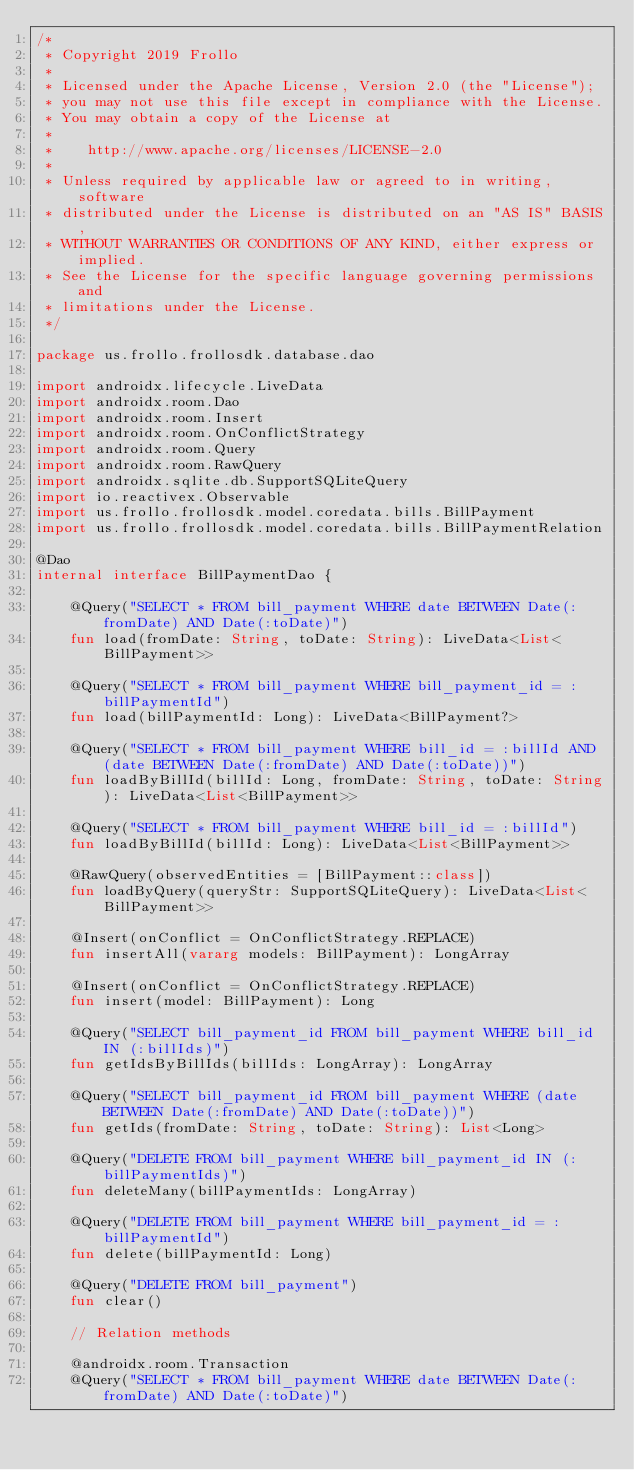Convert code to text. <code><loc_0><loc_0><loc_500><loc_500><_Kotlin_>/*
 * Copyright 2019 Frollo
 *
 * Licensed under the Apache License, Version 2.0 (the "License");
 * you may not use this file except in compliance with the License.
 * You may obtain a copy of the License at
 *
 *    http://www.apache.org/licenses/LICENSE-2.0
 *
 * Unless required by applicable law or agreed to in writing, software
 * distributed under the License is distributed on an "AS IS" BASIS,
 * WITHOUT WARRANTIES OR CONDITIONS OF ANY KIND, either express or implied.
 * See the License for the specific language governing permissions and
 * limitations under the License.
 */

package us.frollo.frollosdk.database.dao

import androidx.lifecycle.LiveData
import androidx.room.Dao
import androidx.room.Insert
import androidx.room.OnConflictStrategy
import androidx.room.Query
import androidx.room.RawQuery
import androidx.sqlite.db.SupportSQLiteQuery
import io.reactivex.Observable
import us.frollo.frollosdk.model.coredata.bills.BillPayment
import us.frollo.frollosdk.model.coredata.bills.BillPaymentRelation

@Dao
internal interface BillPaymentDao {

    @Query("SELECT * FROM bill_payment WHERE date BETWEEN Date(:fromDate) AND Date(:toDate)")
    fun load(fromDate: String, toDate: String): LiveData<List<BillPayment>>

    @Query("SELECT * FROM bill_payment WHERE bill_payment_id = :billPaymentId")
    fun load(billPaymentId: Long): LiveData<BillPayment?>

    @Query("SELECT * FROM bill_payment WHERE bill_id = :billId AND (date BETWEEN Date(:fromDate) AND Date(:toDate))")
    fun loadByBillId(billId: Long, fromDate: String, toDate: String): LiveData<List<BillPayment>>

    @Query("SELECT * FROM bill_payment WHERE bill_id = :billId")
    fun loadByBillId(billId: Long): LiveData<List<BillPayment>>

    @RawQuery(observedEntities = [BillPayment::class])
    fun loadByQuery(queryStr: SupportSQLiteQuery): LiveData<List<BillPayment>>

    @Insert(onConflict = OnConflictStrategy.REPLACE)
    fun insertAll(vararg models: BillPayment): LongArray

    @Insert(onConflict = OnConflictStrategy.REPLACE)
    fun insert(model: BillPayment): Long

    @Query("SELECT bill_payment_id FROM bill_payment WHERE bill_id IN (:billIds)")
    fun getIdsByBillIds(billIds: LongArray): LongArray

    @Query("SELECT bill_payment_id FROM bill_payment WHERE (date BETWEEN Date(:fromDate) AND Date(:toDate))")
    fun getIds(fromDate: String, toDate: String): List<Long>

    @Query("DELETE FROM bill_payment WHERE bill_payment_id IN (:billPaymentIds)")
    fun deleteMany(billPaymentIds: LongArray)

    @Query("DELETE FROM bill_payment WHERE bill_payment_id = :billPaymentId")
    fun delete(billPaymentId: Long)

    @Query("DELETE FROM bill_payment")
    fun clear()

    // Relation methods

    @androidx.room.Transaction
    @Query("SELECT * FROM bill_payment WHERE date BETWEEN Date(:fromDate) AND Date(:toDate)")</code> 